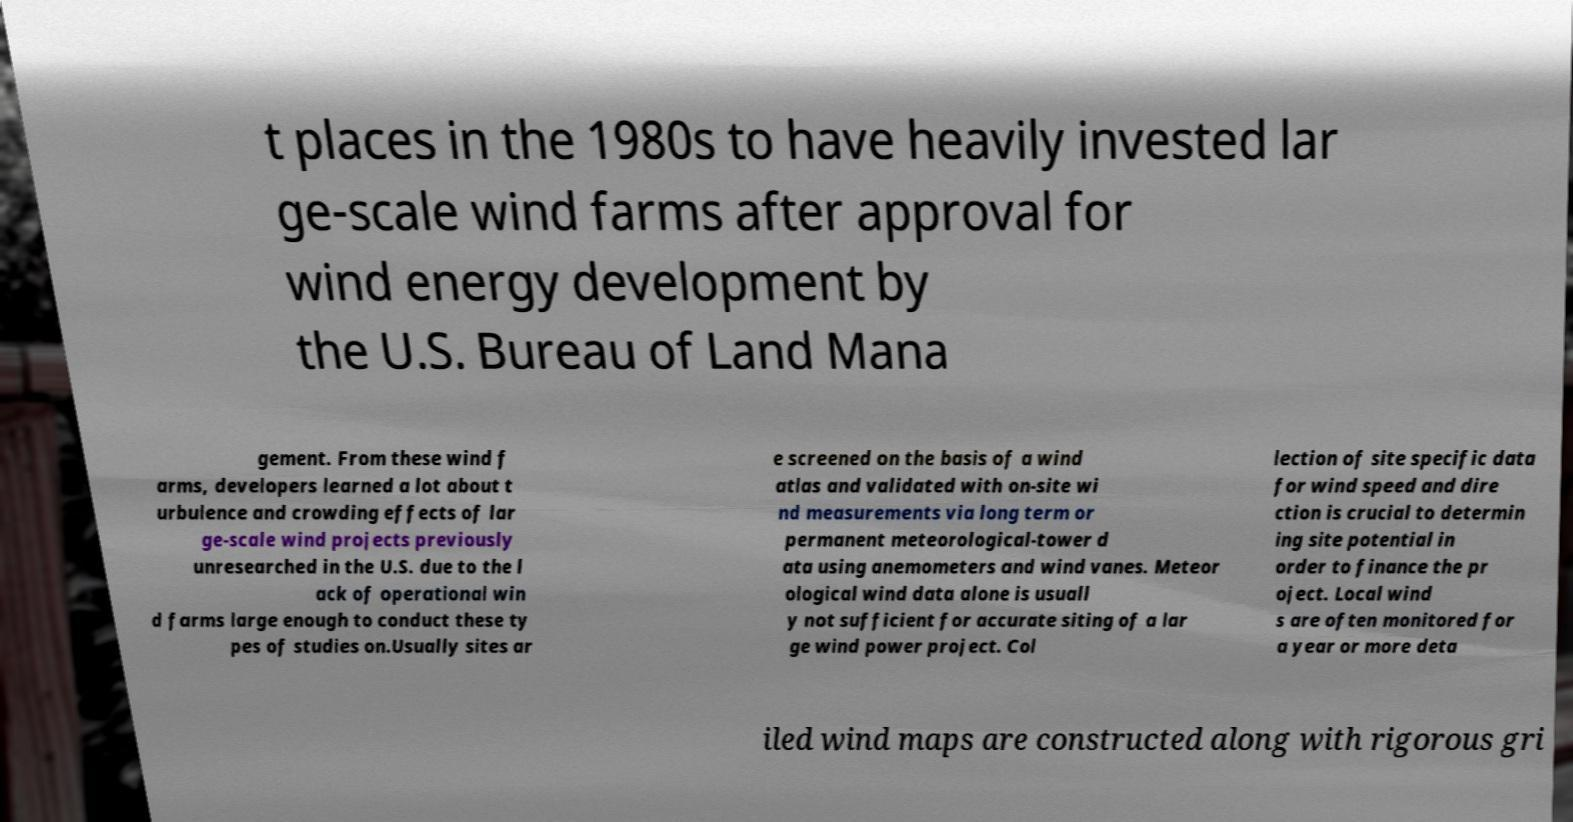Could you extract and type out the text from this image? t places in the 1980s to have heavily invested lar ge-scale wind farms after approval for wind energy development by the U.S. Bureau of Land Mana gement. From these wind f arms, developers learned a lot about t urbulence and crowding effects of lar ge-scale wind projects previously unresearched in the U.S. due to the l ack of operational win d farms large enough to conduct these ty pes of studies on.Usually sites ar e screened on the basis of a wind atlas and validated with on-site wi nd measurements via long term or permanent meteorological-tower d ata using anemometers and wind vanes. Meteor ological wind data alone is usuall y not sufficient for accurate siting of a lar ge wind power project. Col lection of site specific data for wind speed and dire ction is crucial to determin ing site potential in order to finance the pr oject. Local wind s are often monitored for a year or more deta iled wind maps are constructed along with rigorous gri 